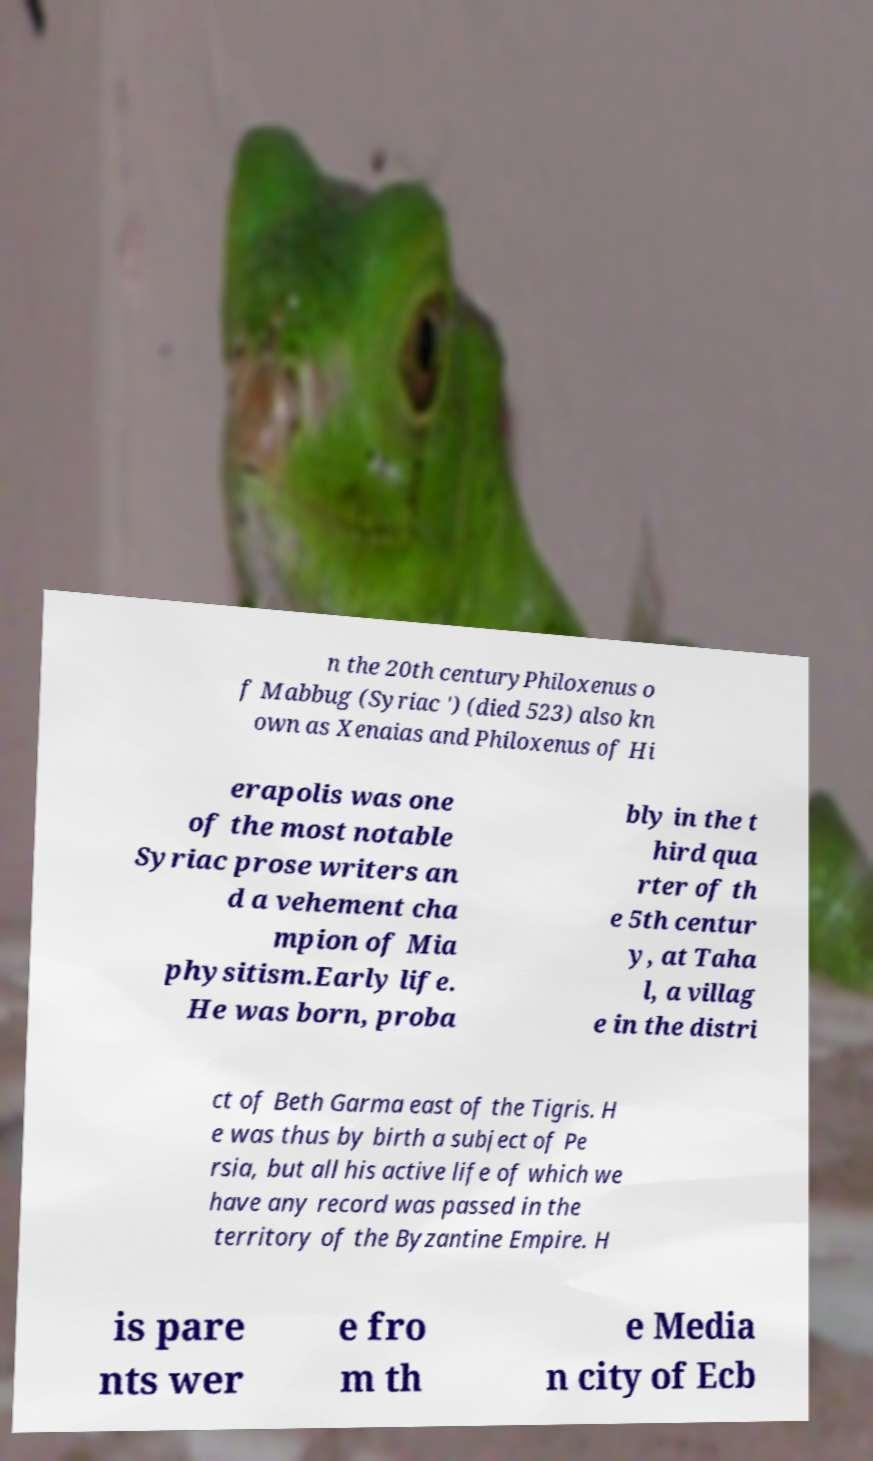I need the written content from this picture converted into text. Can you do that? n the 20th centuryPhiloxenus o f Mabbug (Syriac ') (died 523) also kn own as Xenaias and Philoxenus of Hi erapolis was one of the most notable Syriac prose writers an d a vehement cha mpion of Mia physitism.Early life. He was born, proba bly in the t hird qua rter of th e 5th centur y, at Taha l, a villag e in the distri ct of Beth Garma east of the Tigris. H e was thus by birth a subject of Pe rsia, but all his active life of which we have any record was passed in the territory of the Byzantine Empire. H is pare nts wer e fro m th e Media n city of Ecb 